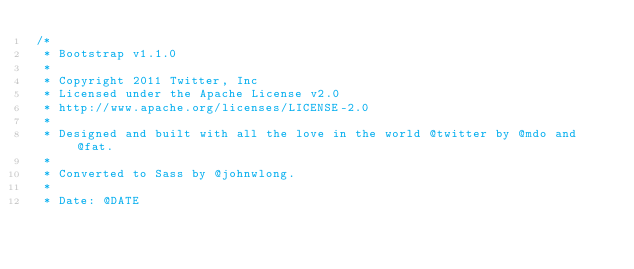Convert code to text. <code><loc_0><loc_0><loc_500><loc_500><_CSS_>/*
 * Bootstrap v1.1.0
 *
 * Copyright 2011 Twitter, Inc
 * Licensed under the Apache License v2.0
 * http://www.apache.org/licenses/LICENSE-2.0
 *
 * Designed and built with all the love in the world @twitter by @mdo and @fat.
 *
 * Converted to Sass by @johnwlong.
 *
 * Date: @DATE</code> 